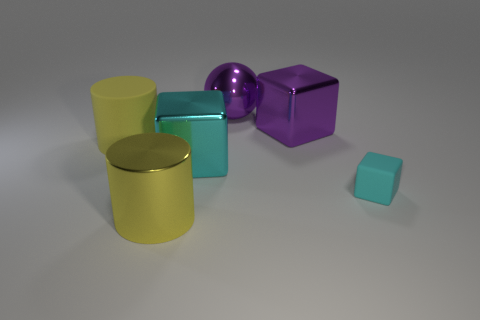Subtract all rubber cubes. How many cubes are left? 2 Subtract all purple cubes. How many cubes are left? 2 Add 5 big purple things. How many big purple things exist? 7 Add 3 cyan metal cubes. How many objects exist? 9 Subtract 0 blue cylinders. How many objects are left? 6 Subtract all cylinders. How many objects are left? 4 Subtract 3 cubes. How many cubes are left? 0 Subtract all green spheres. Subtract all blue cylinders. How many spheres are left? 1 Subtract all red balls. How many gray blocks are left? 0 Subtract all big purple things. Subtract all small cyan things. How many objects are left? 3 